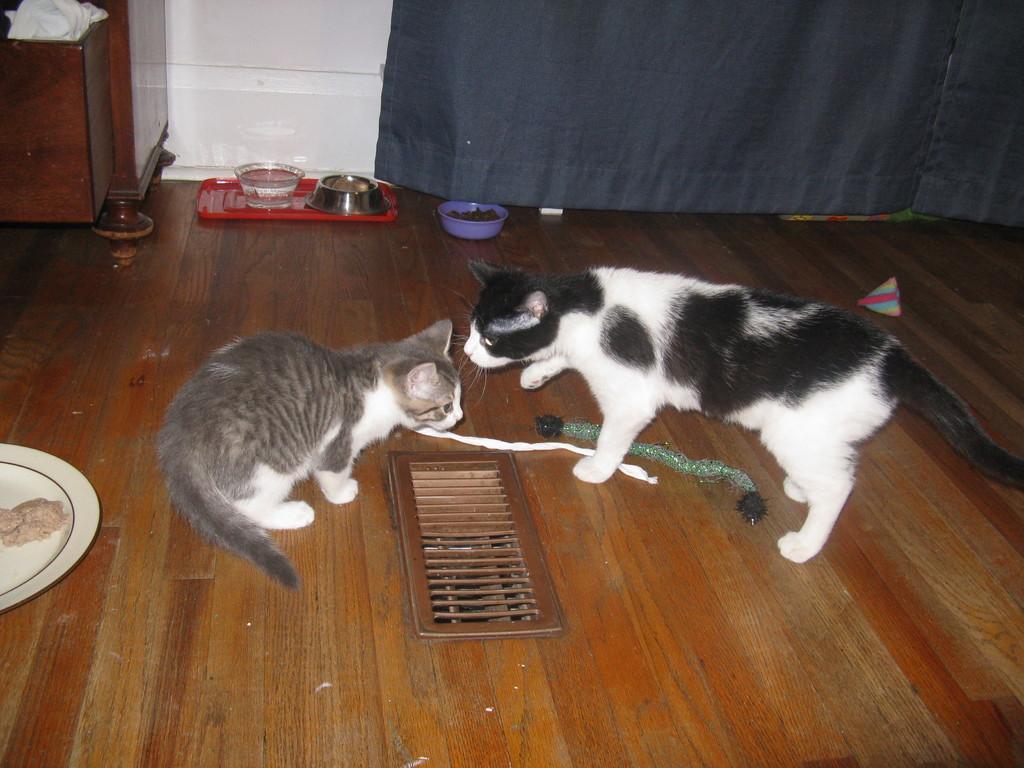Could you give a brief overview of what you see in this image? In this image I can see the brown colored floor on which I can see two cats which are white, black and grey in color. I can see the red colored tray, few bowls, a plate, the grey colored curtain, the white colored wall and a wooden furniture which is brown in color. 